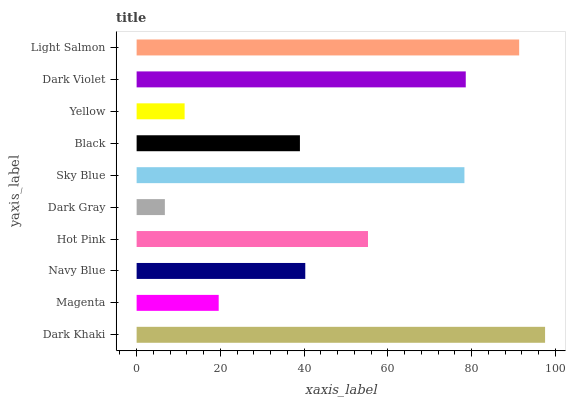Is Dark Gray the minimum?
Answer yes or no. Yes. Is Dark Khaki the maximum?
Answer yes or no. Yes. Is Magenta the minimum?
Answer yes or no. No. Is Magenta the maximum?
Answer yes or no. No. Is Dark Khaki greater than Magenta?
Answer yes or no. Yes. Is Magenta less than Dark Khaki?
Answer yes or no. Yes. Is Magenta greater than Dark Khaki?
Answer yes or no. No. Is Dark Khaki less than Magenta?
Answer yes or no. No. Is Hot Pink the high median?
Answer yes or no. Yes. Is Navy Blue the low median?
Answer yes or no. Yes. Is Sky Blue the high median?
Answer yes or no. No. Is Black the low median?
Answer yes or no. No. 